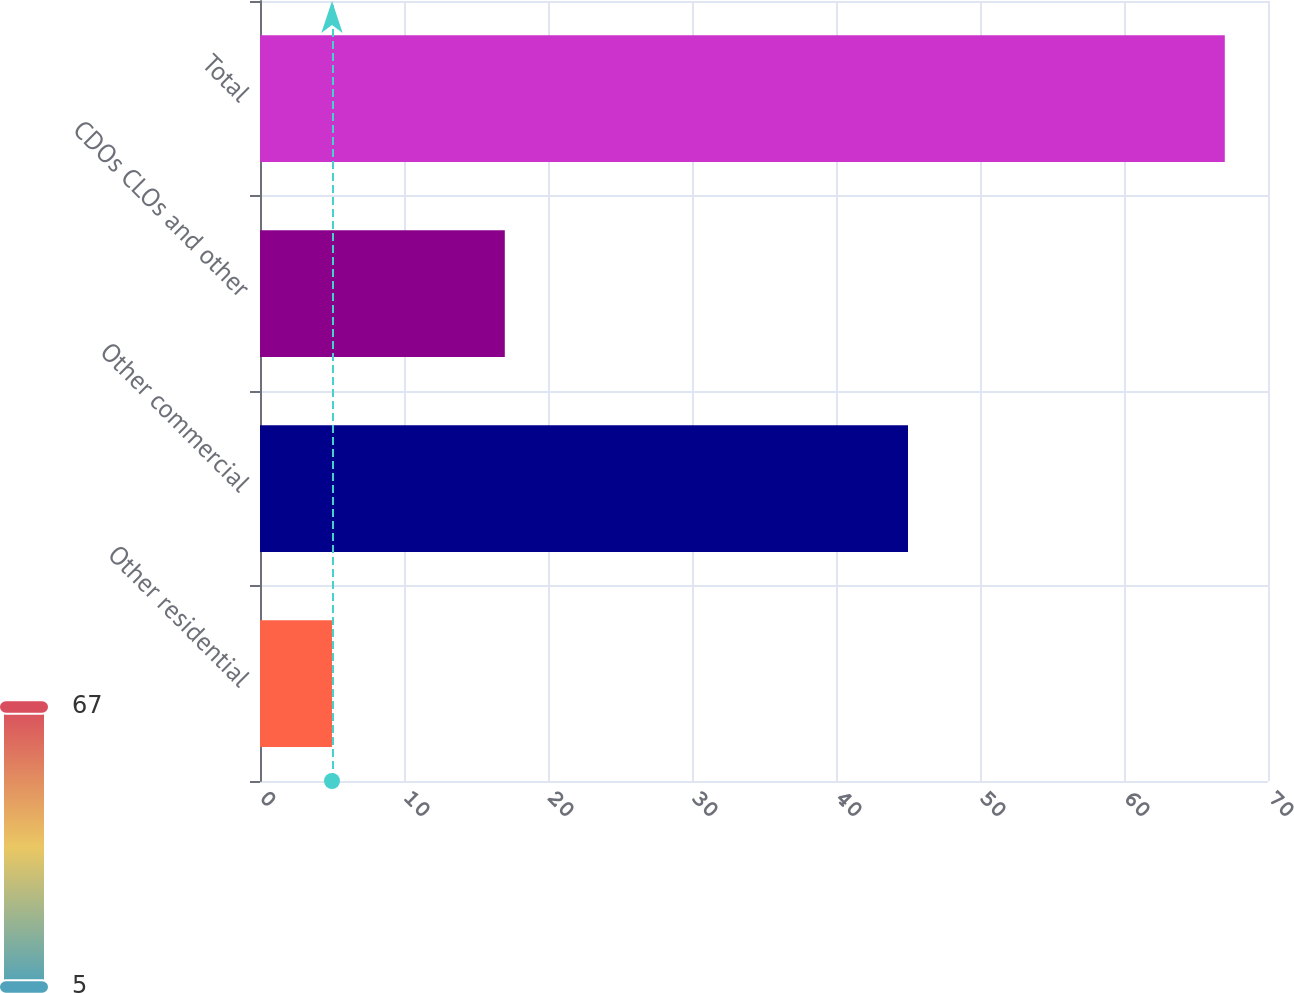<chart> <loc_0><loc_0><loc_500><loc_500><bar_chart><fcel>Other residential<fcel>Other commercial<fcel>CDOs CLOs and other<fcel>Total<nl><fcel>5<fcel>45<fcel>17<fcel>67<nl></chart> 